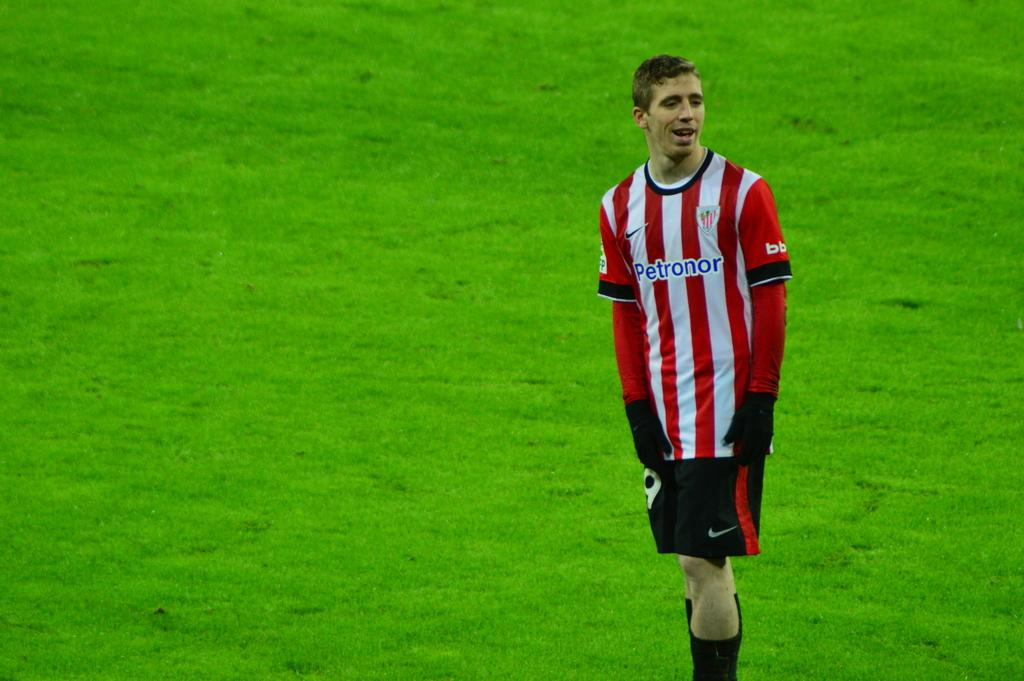<image>
Relay a brief, clear account of the picture shown. A lone footballer wearing a red and white stripe top with Petonor on it stands on the pitch 